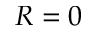<formula> <loc_0><loc_0><loc_500><loc_500>R = 0</formula> 